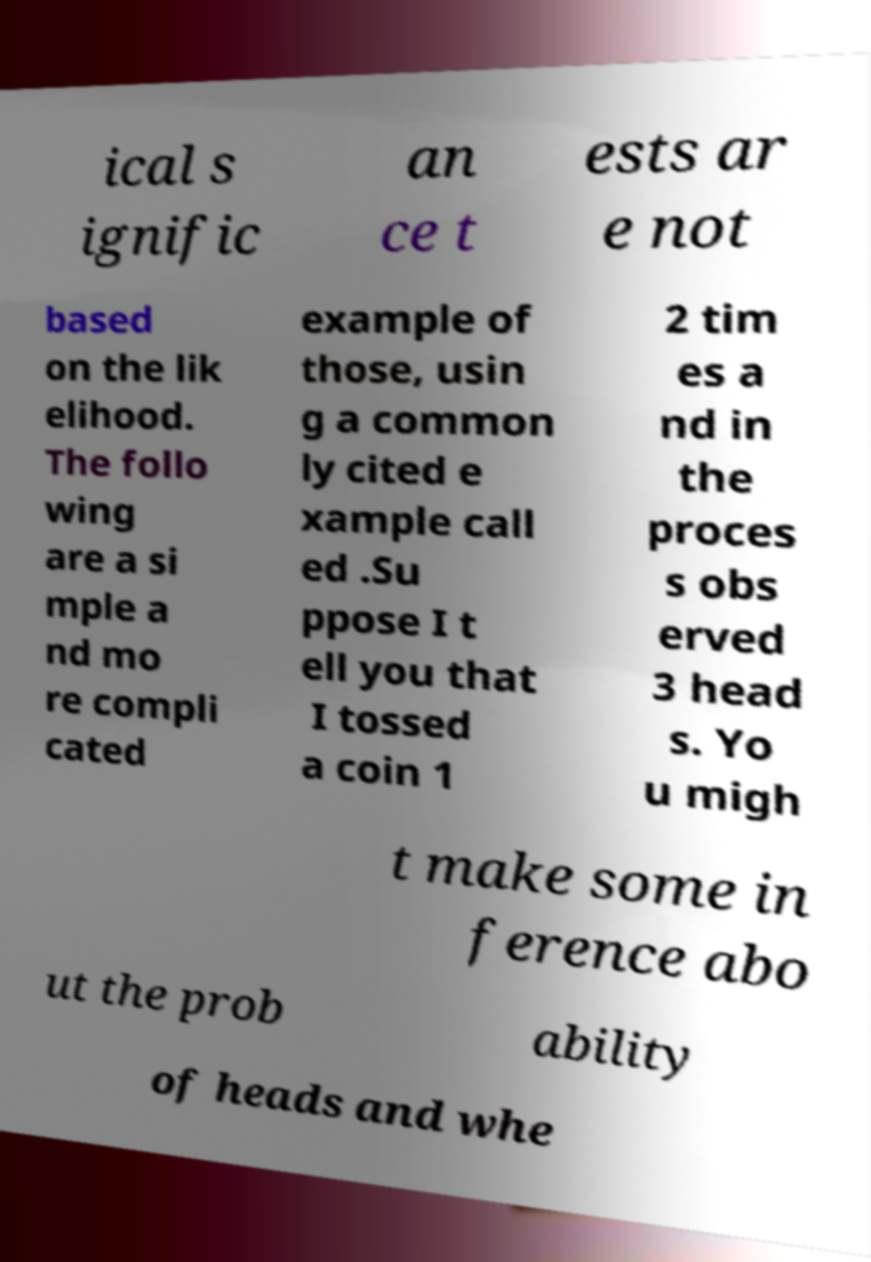Please identify and transcribe the text found in this image. ical s ignific an ce t ests ar e not based on the lik elihood. The follo wing are a si mple a nd mo re compli cated example of those, usin g a common ly cited e xample call ed .Su ppose I t ell you that I tossed a coin 1 2 tim es a nd in the proces s obs erved 3 head s. Yo u migh t make some in ference abo ut the prob ability of heads and whe 